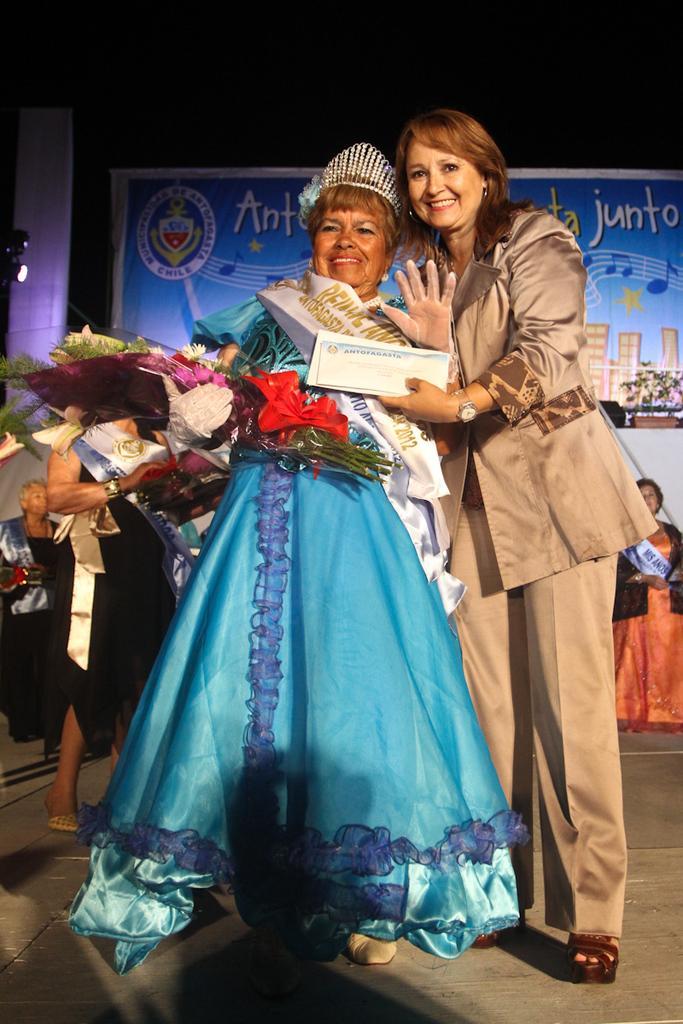In one or two sentences, can you explain what this image depicts? In the picture I can see some people and she is holding bouquet, behind we can see few people and banner. 